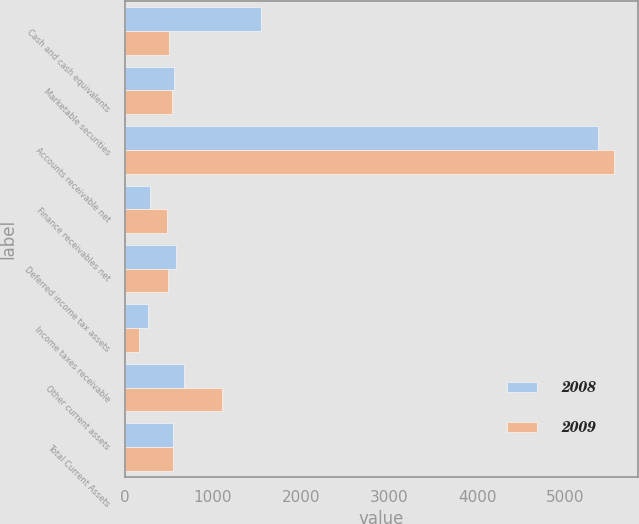Convert chart to OTSL. <chart><loc_0><loc_0><loc_500><loc_500><stacked_bar_chart><ecel><fcel>Cash and cash equivalents<fcel>Marketable securities<fcel>Accounts receivable net<fcel>Finance receivables net<fcel>Deferred income tax assets<fcel>Income taxes receivable<fcel>Other current assets<fcel>Total Current Assets<nl><fcel>2008<fcel>1542<fcel>558<fcel>5369<fcel>287<fcel>585<fcel>266<fcel>668<fcel>550<nl><fcel>2009<fcel>507<fcel>542<fcel>5547<fcel>480<fcel>494<fcel>167<fcel>1108<fcel>550<nl></chart> 